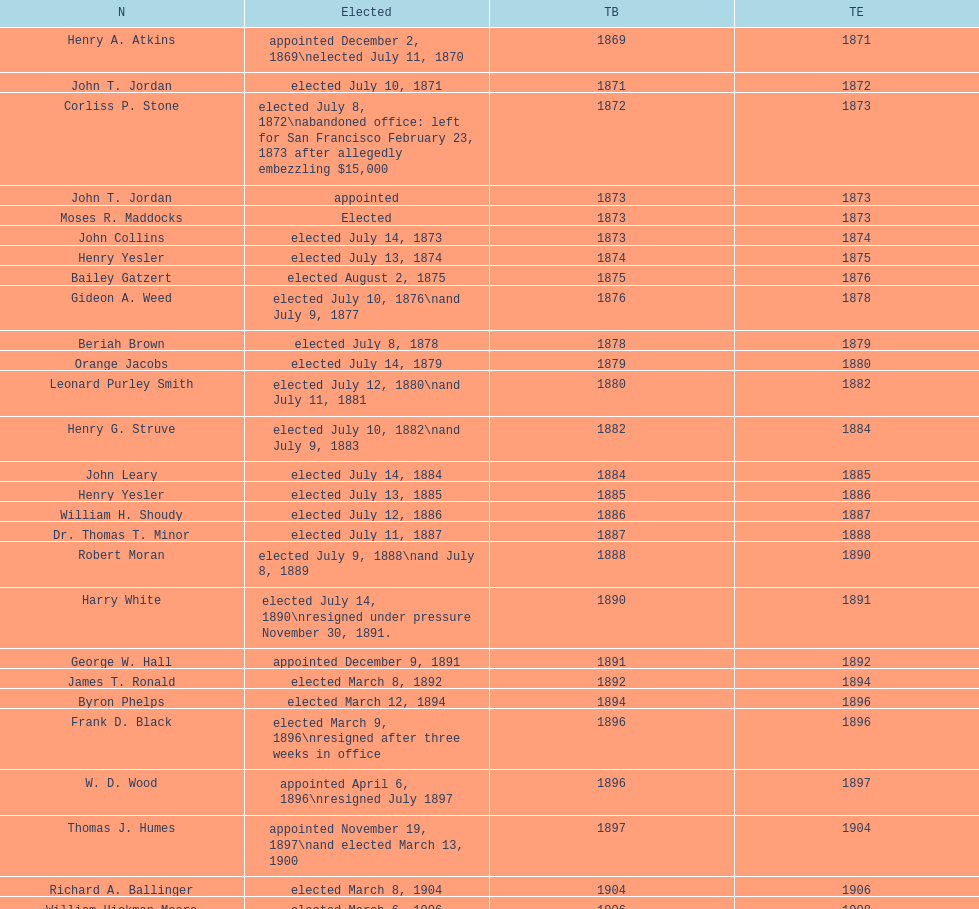Who was the mayor before jordan? Henry A. Atkins. 